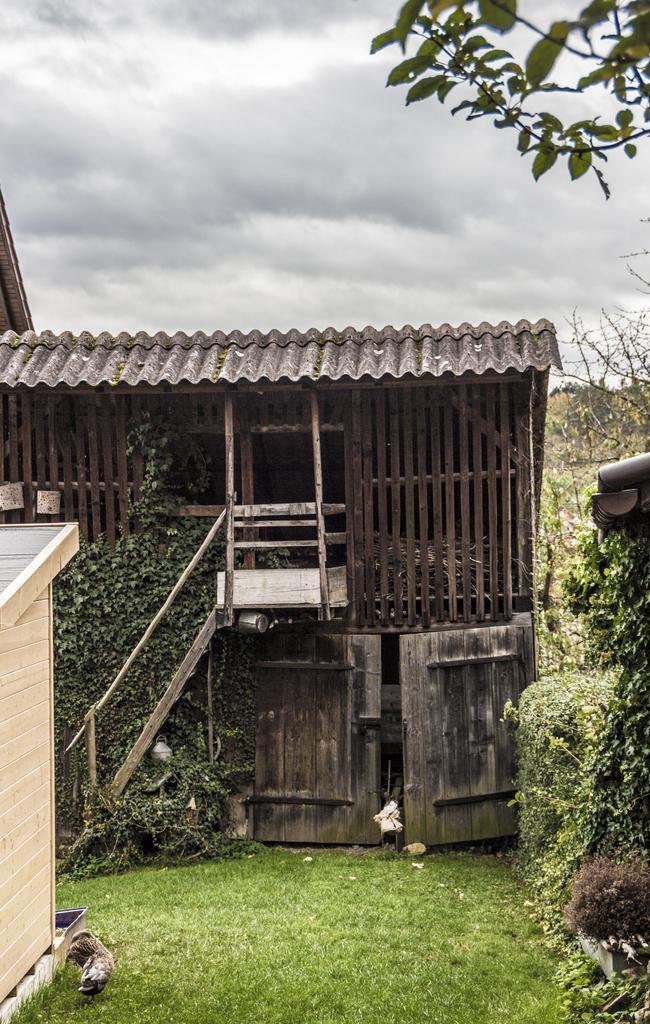How would you summarize this image in a sentence or two? In the image there is a wooden house and around that there are many trees and there is a grass in front of that house. 